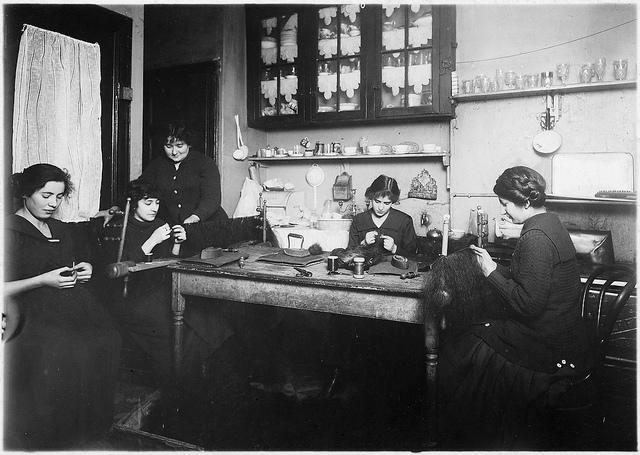How many bottles are on the shelf?
Keep it brief. 5. What era was this taken in?
Be succinct. 20s. Is this in someone's house?
Answer briefly. Yes. Could this be a "sewing" bee?
Short answer required. Yes. It could be?
Be succinct. Yes. Are they happy or sad?
Be succinct. Sad. What kind of camera was used for this photograph?
Quick response, please. Black and white. How many people are there?
Keep it brief. 5. 